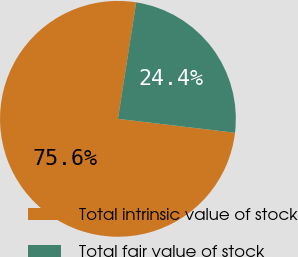Convert chart to OTSL. <chart><loc_0><loc_0><loc_500><loc_500><pie_chart><fcel>Total intrinsic value of stock<fcel>Total fair value of stock<nl><fcel>75.59%<fcel>24.41%<nl></chart> 